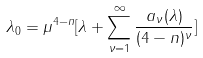Convert formula to latex. <formula><loc_0><loc_0><loc_500><loc_500>\lambda _ { 0 } = \mu ^ { 4 - n } [ \lambda + \sum _ { \nu = 1 } ^ { \infty } \frac { a _ { \nu } ( \lambda ) } { ( 4 - n ) ^ { \nu } } ]</formula> 